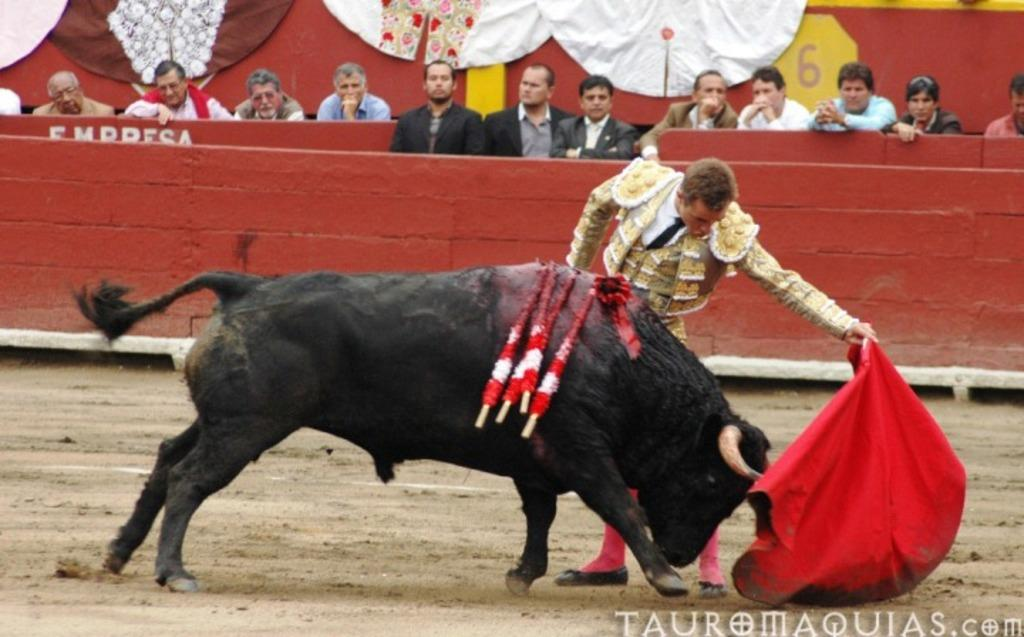What can be seen in the image involving multiple individuals? There is a group of people in the image. What animal is present in the image? There is a bull in the image. Can you describe the man in the image? A man is present in the image, and he is holding a cloth. How far away are the ants from the bull in the image? There are no ants present in the image, so it is not possible to determine their distance from the bull. 